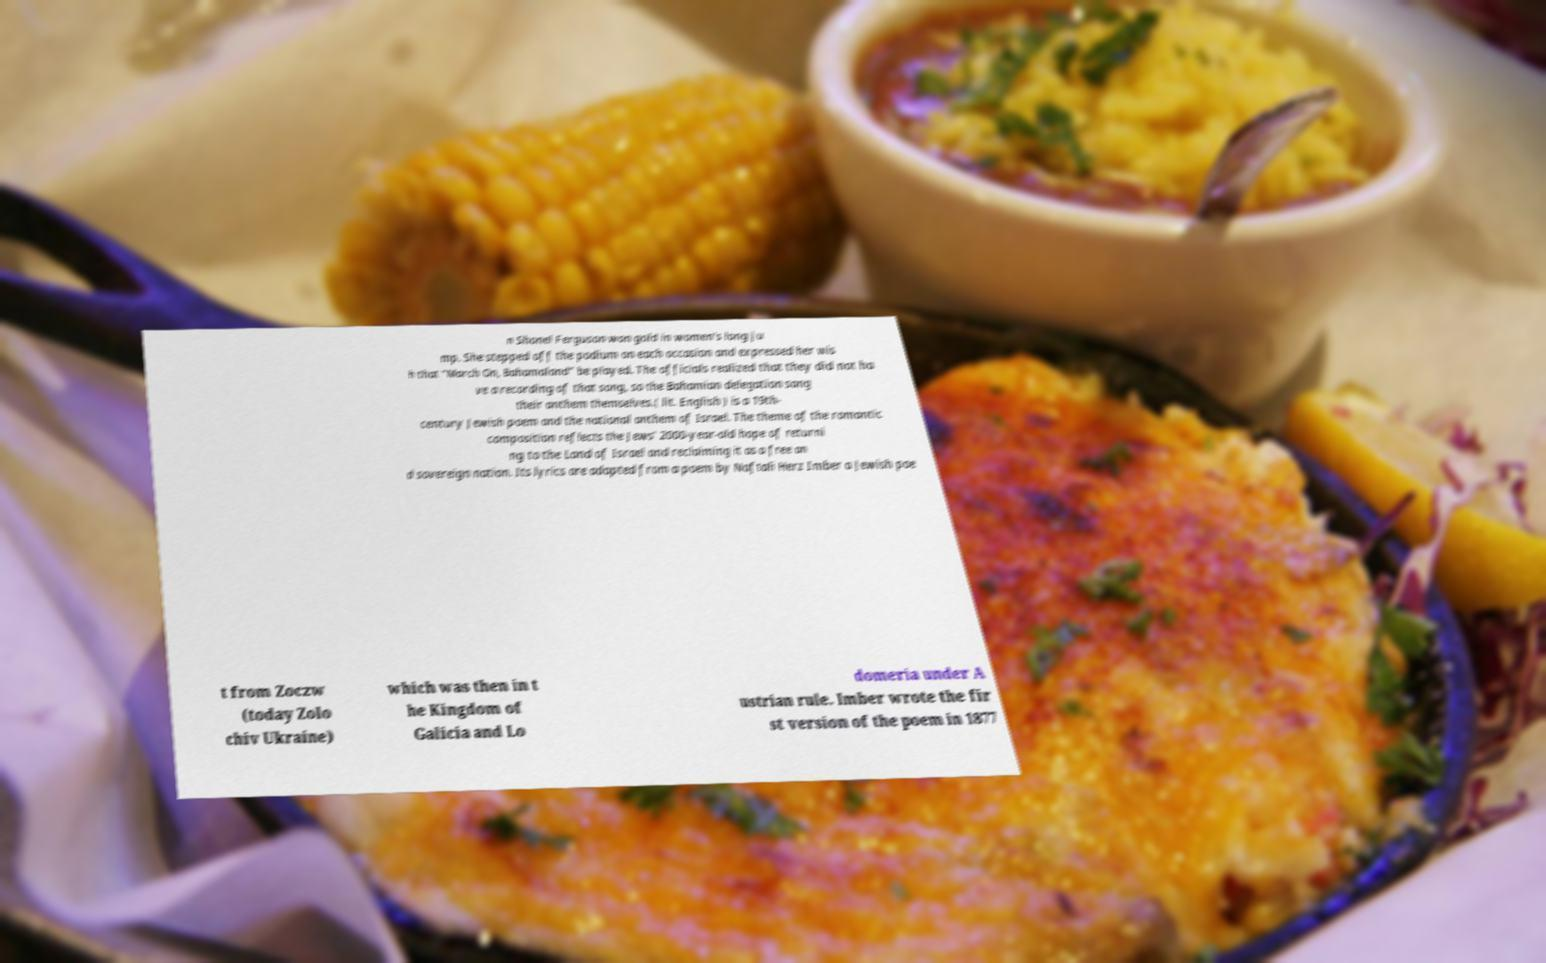For documentation purposes, I need the text within this image transcribed. Could you provide that? n Shonel Ferguson won gold in women's long ju mp. She stepped off the podium on each occasion and expressed her wis h that "March On, Bahamaland" be played. The officials realized that they did not ha ve a recording of that song, so the Bahamian delegation sang their anthem themselves.( lit. English ) is a 19th- century Jewish poem and the national anthem of Israel. The theme of the romantic composition reflects the Jews' 2000-year-old hope of returni ng to the Land of Israel and reclaiming it as a free an d sovereign nation. Its lyrics are adapted from a poem by Naftali Herz Imber a Jewish poe t from Zoczw (today Zolo chiv Ukraine) which was then in t he Kingdom of Galicia and Lo domeria under A ustrian rule. Imber wrote the fir st version of the poem in 1877 